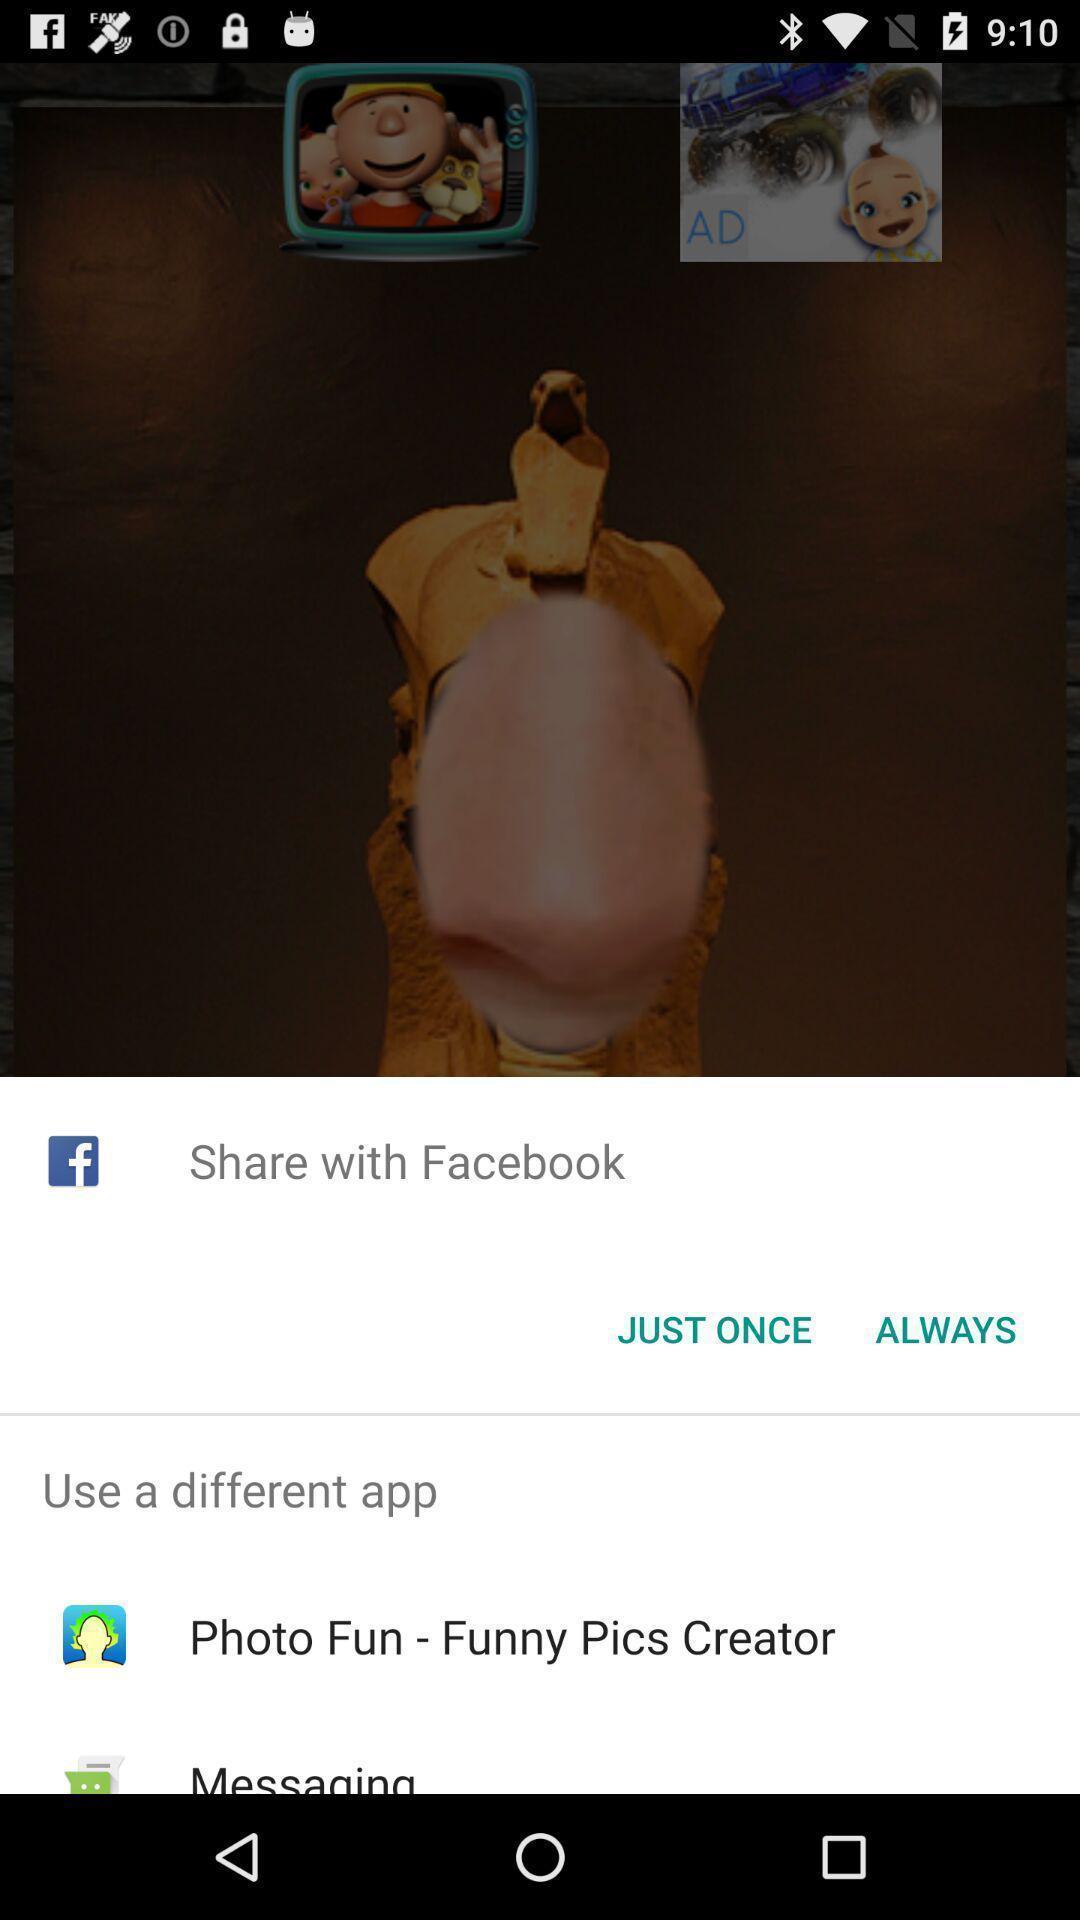Explain the elements present in this screenshot. Pop-up showing different sharing options. 